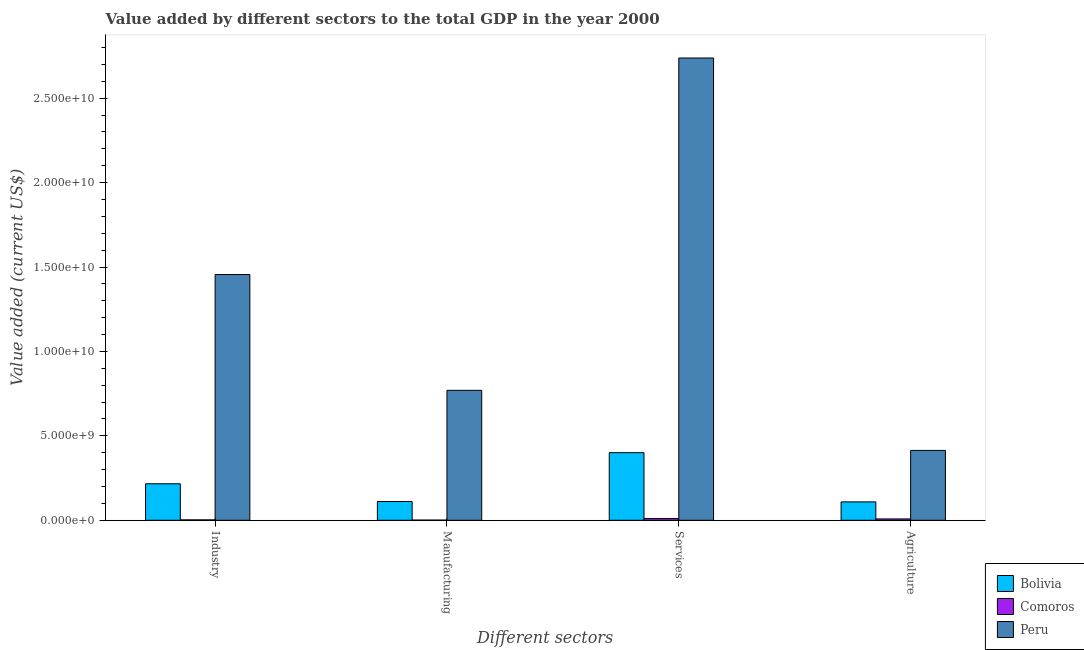How many groups of bars are there?
Offer a terse response. 4. Are the number of bars per tick equal to the number of legend labels?
Your response must be concise. Yes. Are the number of bars on each tick of the X-axis equal?
Give a very brief answer. Yes. How many bars are there on the 3rd tick from the right?
Your answer should be very brief. 3. What is the label of the 2nd group of bars from the left?
Offer a very short reply. Manufacturing. What is the value added by manufacturing sector in Comoros?
Make the answer very short. 8.76e+06. Across all countries, what is the maximum value added by manufacturing sector?
Ensure brevity in your answer.  7.70e+09. Across all countries, what is the minimum value added by industrial sector?
Make the answer very short. 2.29e+07. In which country was the value added by manufacturing sector minimum?
Ensure brevity in your answer.  Comoros. What is the total value added by services sector in the graph?
Offer a very short reply. 3.15e+1. What is the difference between the value added by agricultural sector in Peru and that in Comoros?
Your response must be concise. 4.06e+09. What is the difference between the value added by services sector in Comoros and the value added by agricultural sector in Bolivia?
Your response must be concise. -9.87e+08. What is the average value added by industrial sector per country?
Give a very brief answer. 5.58e+09. What is the difference between the value added by agricultural sector and value added by manufacturing sector in Bolivia?
Give a very brief answer. -2.31e+07. What is the ratio of the value added by industrial sector in Peru to that in Bolivia?
Your answer should be very brief. 6.73. What is the difference between the highest and the second highest value added by agricultural sector?
Give a very brief answer. 3.05e+09. What is the difference between the highest and the lowest value added by agricultural sector?
Your answer should be compact. 4.06e+09. In how many countries, is the value added by industrial sector greater than the average value added by industrial sector taken over all countries?
Make the answer very short. 1. Is the sum of the value added by services sector in Comoros and Peru greater than the maximum value added by manufacturing sector across all countries?
Your answer should be very brief. Yes. What does the 2nd bar from the left in Manufacturing represents?
Give a very brief answer. Comoros. What does the 2nd bar from the right in Manufacturing represents?
Your response must be concise. Comoros. Is it the case that in every country, the sum of the value added by industrial sector and value added by manufacturing sector is greater than the value added by services sector?
Offer a terse response. No. How many bars are there?
Your answer should be very brief. 12. How many countries are there in the graph?
Provide a short and direct response. 3. Are the values on the major ticks of Y-axis written in scientific E-notation?
Offer a very short reply. Yes. Where does the legend appear in the graph?
Your answer should be very brief. Bottom right. How many legend labels are there?
Provide a short and direct response. 3. What is the title of the graph?
Make the answer very short. Value added by different sectors to the total GDP in the year 2000. Does "Samoa" appear as one of the legend labels in the graph?
Keep it short and to the point. No. What is the label or title of the X-axis?
Ensure brevity in your answer.  Different sectors. What is the label or title of the Y-axis?
Your answer should be compact. Value added (current US$). What is the Value added (current US$) in Bolivia in Industry?
Keep it short and to the point. 2.16e+09. What is the Value added (current US$) in Comoros in Industry?
Ensure brevity in your answer.  2.29e+07. What is the Value added (current US$) in Peru in Industry?
Ensure brevity in your answer.  1.46e+1. What is the Value added (current US$) in Bolivia in Manufacturing?
Make the answer very short. 1.11e+09. What is the Value added (current US$) in Comoros in Manufacturing?
Your response must be concise. 8.76e+06. What is the Value added (current US$) in Peru in Manufacturing?
Offer a terse response. 7.70e+09. What is the Value added (current US$) in Bolivia in Services?
Your answer should be compact. 4.00e+09. What is the Value added (current US$) of Comoros in Services?
Keep it short and to the point. 1.02e+08. What is the Value added (current US$) in Peru in Services?
Make the answer very short. 2.74e+1. What is the Value added (current US$) of Bolivia in Agriculture?
Offer a terse response. 1.09e+09. What is the Value added (current US$) in Comoros in Agriculture?
Offer a very short reply. 7.93e+07. What is the Value added (current US$) in Peru in Agriculture?
Your answer should be very brief. 4.14e+09. Across all Different sectors, what is the maximum Value added (current US$) of Bolivia?
Offer a very short reply. 4.00e+09. Across all Different sectors, what is the maximum Value added (current US$) of Comoros?
Give a very brief answer. 1.02e+08. Across all Different sectors, what is the maximum Value added (current US$) of Peru?
Your response must be concise. 2.74e+1. Across all Different sectors, what is the minimum Value added (current US$) in Bolivia?
Offer a very short reply. 1.09e+09. Across all Different sectors, what is the minimum Value added (current US$) in Comoros?
Provide a short and direct response. 8.76e+06. Across all Different sectors, what is the minimum Value added (current US$) in Peru?
Provide a short and direct response. 4.14e+09. What is the total Value added (current US$) of Bolivia in the graph?
Keep it short and to the point. 8.37e+09. What is the total Value added (current US$) of Comoros in the graph?
Give a very brief answer. 2.13e+08. What is the total Value added (current US$) in Peru in the graph?
Give a very brief answer. 5.38e+1. What is the difference between the Value added (current US$) in Bolivia in Industry and that in Manufacturing?
Provide a short and direct response. 1.05e+09. What is the difference between the Value added (current US$) of Comoros in Industry and that in Manufacturing?
Ensure brevity in your answer.  1.42e+07. What is the difference between the Value added (current US$) of Peru in Industry and that in Manufacturing?
Provide a succinct answer. 6.86e+09. What is the difference between the Value added (current US$) of Bolivia in Industry and that in Services?
Keep it short and to the point. -1.84e+09. What is the difference between the Value added (current US$) of Comoros in Industry and that in Services?
Offer a very short reply. -7.87e+07. What is the difference between the Value added (current US$) in Peru in Industry and that in Services?
Make the answer very short. -1.28e+1. What is the difference between the Value added (current US$) in Bolivia in Industry and that in Agriculture?
Ensure brevity in your answer.  1.07e+09. What is the difference between the Value added (current US$) in Comoros in Industry and that in Agriculture?
Your answer should be very brief. -5.64e+07. What is the difference between the Value added (current US$) of Peru in Industry and that in Agriculture?
Make the answer very short. 1.04e+1. What is the difference between the Value added (current US$) of Bolivia in Manufacturing and that in Services?
Give a very brief answer. -2.89e+09. What is the difference between the Value added (current US$) in Comoros in Manufacturing and that in Services?
Keep it short and to the point. -9.29e+07. What is the difference between the Value added (current US$) in Peru in Manufacturing and that in Services?
Your answer should be compact. -1.97e+1. What is the difference between the Value added (current US$) in Bolivia in Manufacturing and that in Agriculture?
Your response must be concise. 2.31e+07. What is the difference between the Value added (current US$) of Comoros in Manufacturing and that in Agriculture?
Your answer should be compact. -7.05e+07. What is the difference between the Value added (current US$) of Peru in Manufacturing and that in Agriculture?
Keep it short and to the point. 3.56e+09. What is the difference between the Value added (current US$) of Bolivia in Services and that in Agriculture?
Give a very brief answer. 2.92e+09. What is the difference between the Value added (current US$) in Comoros in Services and that in Agriculture?
Provide a short and direct response. 2.24e+07. What is the difference between the Value added (current US$) of Peru in Services and that in Agriculture?
Give a very brief answer. 2.32e+1. What is the difference between the Value added (current US$) in Bolivia in Industry and the Value added (current US$) in Comoros in Manufacturing?
Offer a terse response. 2.15e+09. What is the difference between the Value added (current US$) in Bolivia in Industry and the Value added (current US$) in Peru in Manufacturing?
Offer a very short reply. -5.54e+09. What is the difference between the Value added (current US$) of Comoros in Industry and the Value added (current US$) of Peru in Manufacturing?
Provide a succinct answer. -7.67e+09. What is the difference between the Value added (current US$) in Bolivia in Industry and the Value added (current US$) in Comoros in Services?
Make the answer very short. 2.06e+09. What is the difference between the Value added (current US$) of Bolivia in Industry and the Value added (current US$) of Peru in Services?
Provide a short and direct response. -2.52e+1. What is the difference between the Value added (current US$) in Comoros in Industry and the Value added (current US$) in Peru in Services?
Your answer should be very brief. -2.74e+1. What is the difference between the Value added (current US$) of Bolivia in Industry and the Value added (current US$) of Comoros in Agriculture?
Your answer should be compact. 2.08e+09. What is the difference between the Value added (current US$) of Bolivia in Industry and the Value added (current US$) of Peru in Agriculture?
Make the answer very short. -1.98e+09. What is the difference between the Value added (current US$) of Comoros in Industry and the Value added (current US$) of Peru in Agriculture?
Offer a very short reply. -4.11e+09. What is the difference between the Value added (current US$) of Bolivia in Manufacturing and the Value added (current US$) of Comoros in Services?
Your answer should be compact. 1.01e+09. What is the difference between the Value added (current US$) of Bolivia in Manufacturing and the Value added (current US$) of Peru in Services?
Your answer should be very brief. -2.63e+1. What is the difference between the Value added (current US$) of Comoros in Manufacturing and the Value added (current US$) of Peru in Services?
Ensure brevity in your answer.  -2.74e+1. What is the difference between the Value added (current US$) of Bolivia in Manufacturing and the Value added (current US$) of Comoros in Agriculture?
Give a very brief answer. 1.03e+09. What is the difference between the Value added (current US$) in Bolivia in Manufacturing and the Value added (current US$) in Peru in Agriculture?
Offer a terse response. -3.03e+09. What is the difference between the Value added (current US$) of Comoros in Manufacturing and the Value added (current US$) of Peru in Agriculture?
Offer a terse response. -4.13e+09. What is the difference between the Value added (current US$) in Bolivia in Services and the Value added (current US$) in Comoros in Agriculture?
Ensure brevity in your answer.  3.93e+09. What is the difference between the Value added (current US$) in Bolivia in Services and the Value added (current US$) in Peru in Agriculture?
Your answer should be very brief. -1.33e+08. What is the difference between the Value added (current US$) in Comoros in Services and the Value added (current US$) in Peru in Agriculture?
Your answer should be compact. -4.04e+09. What is the average Value added (current US$) of Bolivia per Different sectors?
Keep it short and to the point. 2.09e+09. What is the average Value added (current US$) in Comoros per Different sectors?
Provide a short and direct response. 5.32e+07. What is the average Value added (current US$) of Peru per Different sectors?
Provide a short and direct response. 1.34e+1. What is the difference between the Value added (current US$) of Bolivia and Value added (current US$) of Comoros in Industry?
Your answer should be compact. 2.14e+09. What is the difference between the Value added (current US$) of Bolivia and Value added (current US$) of Peru in Industry?
Provide a succinct answer. -1.24e+1. What is the difference between the Value added (current US$) in Comoros and Value added (current US$) in Peru in Industry?
Your response must be concise. -1.45e+1. What is the difference between the Value added (current US$) in Bolivia and Value added (current US$) in Comoros in Manufacturing?
Offer a very short reply. 1.10e+09. What is the difference between the Value added (current US$) of Bolivia and Value added (current US$) of Peru in Manufacturing?
Ensure brevity in your answer.  -6.58e+09. What is the difference between the Value added (current US$) in Comoros and Value added (current US$) in Peru in Manufacturing?
Make the answer very short. -7.69e+09. What is the difference between the Value added (current US$) in Bolivia and Value added (current US$) in Comoros in Services?
Your answer should be very brief. 3.90e+09. What is the difference between the Value added (current US$) in Bolivia and Value added (current US$) in Peru in Services?
Offer a very short reply. -2.34e+1. What is the difference between the Value added (current US$) of Comoros and Value added (current US$) of Peru in Services?
Give a very brief answer. -2.73e+1. What is the difference between the Value added (current US$) in Bolivia and Value added (current US$) in Comoros in Agriculture?
Your answer should be compact. 1.01e+09. What is the difference between the Value added (current US$) in Bolivia and Value added (current US$) in Peru in Agriculture?
Provide a succinct answer. -3.05e+09. What is the difference between the Value added (current US$) in Comoros and Value added (current US$) in Peru in Agriculture?
Offer a very short reply. -4.06e+09. What is the ratio of the Value added (current US$) in Bolivia in Industry to that in Manufacturing?
Give a very brief answer. 1.94. What is the ratio of the Value added (current US$) of Comoros in Industry to that in Manufacturing?
Offer a terse response. 2.62. What is the ratio of the Value added (current US$) of Peru in Industry to that in Manufacturing?
Offer a very short reply. 1.89. What is the ratio of the Value added (current US$) of Bolivia in Industry to that in Services?
Make the answer very short. 0.54. What is the ratio of the Value added (current US$) of Comoros in Industry to that in Services?
Offer a very short reply. 0.23. What is the ratio of the Value added (current US$) in Peru in Industry to that in Services?
Offer a terse response. 0.53. What is the ratio of the Value added (current US$) in Bolivia in Industry to that in Agriculture?
Offer a very short reply. 1.99. What is the ratio of the Value added (current US$) of Comoros in Industry to that in Agriculture?
Your answer should be very brief. 0.29. What is the ratio of the Value added (current US$) in Peru in Industry to that in Agriculture?
Ensure brevity in your answer.  3.52. What is the ratio of the Value added (current US$) in Bolivia in Manufacturing to that in Services?
Provide a succinct answer. 0.28. What is the ratio of the Value added (current US$) in Comoros in Manufacturing to that in Services?
Ensure brevity in your answer.  0.09. What is the ratio of the Value added (current US$) in Peru in Manufacturing to that in Services?
Ensure brevity in your answer.  0.28. What is the ratio of the Value added (current US$) of Bolivia in Manufacturing to that in Agriculture?
Your response must be concise. 1.02. What is the ratio of the Value added (current US$) in Comoros in Manufacturing to that in Agriculture?
Your response must be concise. 0.11. What is the ratio of the Value added (current US$) of Peru in Manufacturing to that in Agriculture?
Offer a terse response. 1.86. What is the ratio of the Value added (current US$) in Bolivia in Services to that in Agriculture?
Provide a short and direct response. 3.68. What is the ratio of the Value added (current US$) in Comoros in Services to that in Agriculture?
Provide a short and direct response. 1.28. What is the ratio of the Value added (current US$) of Peru in Services to that in Agriculture?
Provide a short and direct response. 6.62. What is the difference between the highest and the second highest Value added (current US$) in Bolivia?
Ensure brevity in your answer.  1.84e+09. What is the difference between the highest and the second highest Value added (current US$) in Comoros?
Keep it short and to the point. 2.24e+07. What is the difference between the highest and the second highest Value added (current US$) in Peru?
Your answer should be very brief. 1.28e+1. What is the difference between the highest and the lowest Value added (current US$) of Bolivia?
Provide a short and direct response. 2.92e+09. What is the difference between the highest and the lowest Value added (current US$) in Comoros?
Your answer should be very brief. 9.29e+07. What is the difference between the highest and the lowest Value added (current US$) in Peru?
Offer a very short reply. 2.32e+1. 